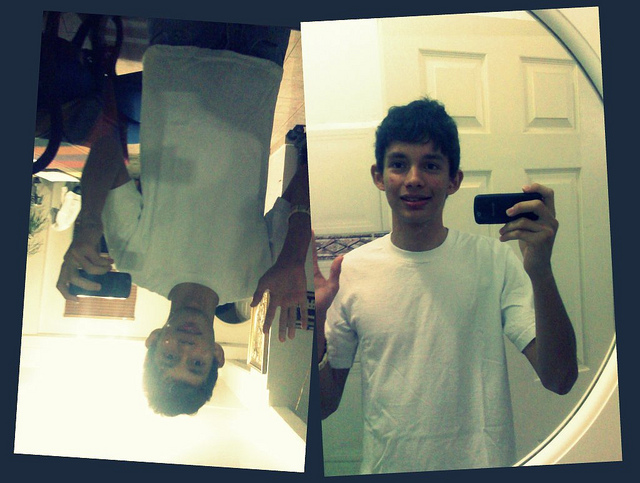Describe the person's hairstyle. The person has short, dark hair that appears slightly tousled, giving it a casual and relaxed look. Could the hairstyle and overall look give any indications about the person's personality or hobbies? The individual's hairstyle and casual outfit suggest a laid-back and approachable personality. The use of a mirror to create a unique selfie could indicate a creative streak and a love for photography. This person might enjoy exploring artistic expression through everyday activities. 